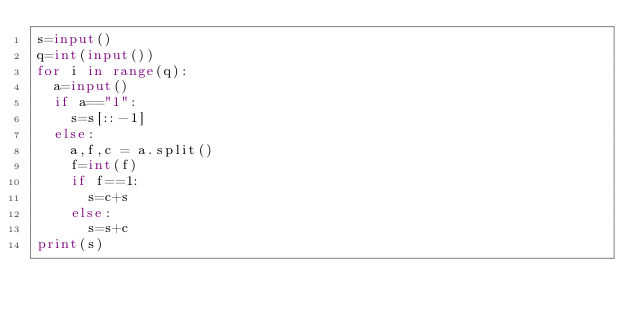Convert code to text. <code><loc_0><loc_0><loc_500><loc_500><_Python_>s=input()
q=int(input())
for i in range(q):
	a=input()
	if a=="1":
		s=s[::-1]
	else:
		a,f,c = a.split()
		f=int(f)
		if f==1:
			s=c+s
		else:
			s=s+c
print(s)</code> 